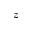Convert formula to latex. <formula><loc_0><loc_0><loc_500><loc_500>z</formula> 